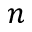<formula> <loc_0><loc_0><loc_500><loc_500>n</formula> 